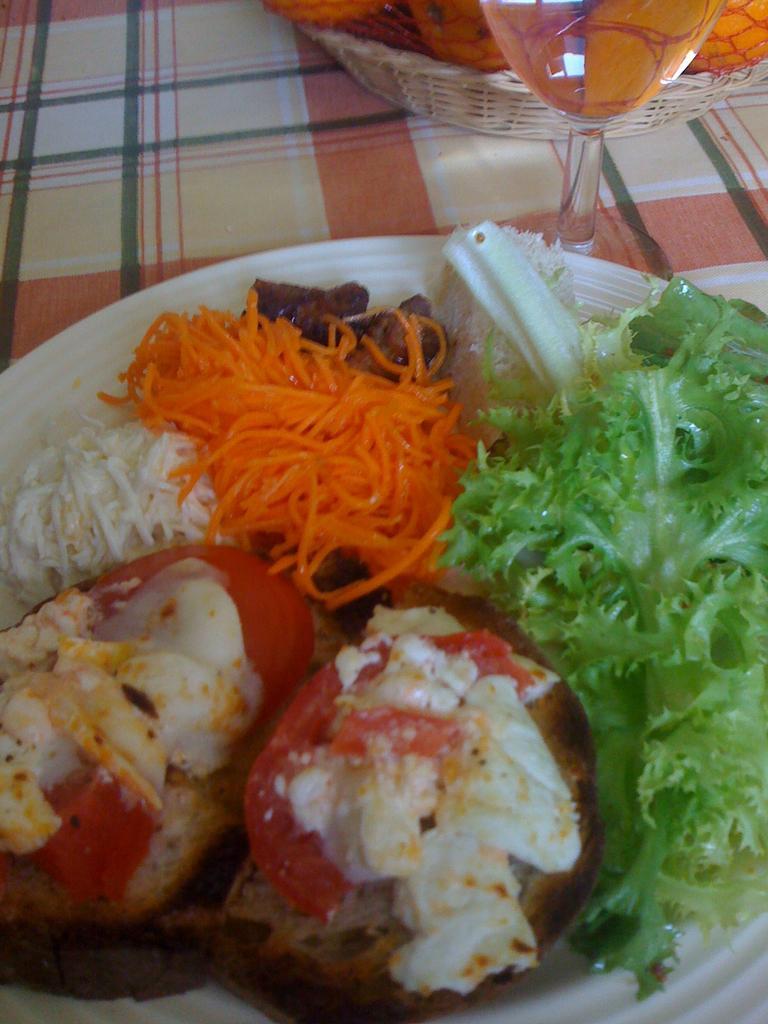Please provide a concise description of this image. In this image there is a food item on the plate in the foreground. There is a glass and a basket with fruits in it on the right corner. And it looks like a tablecloth in the background. 